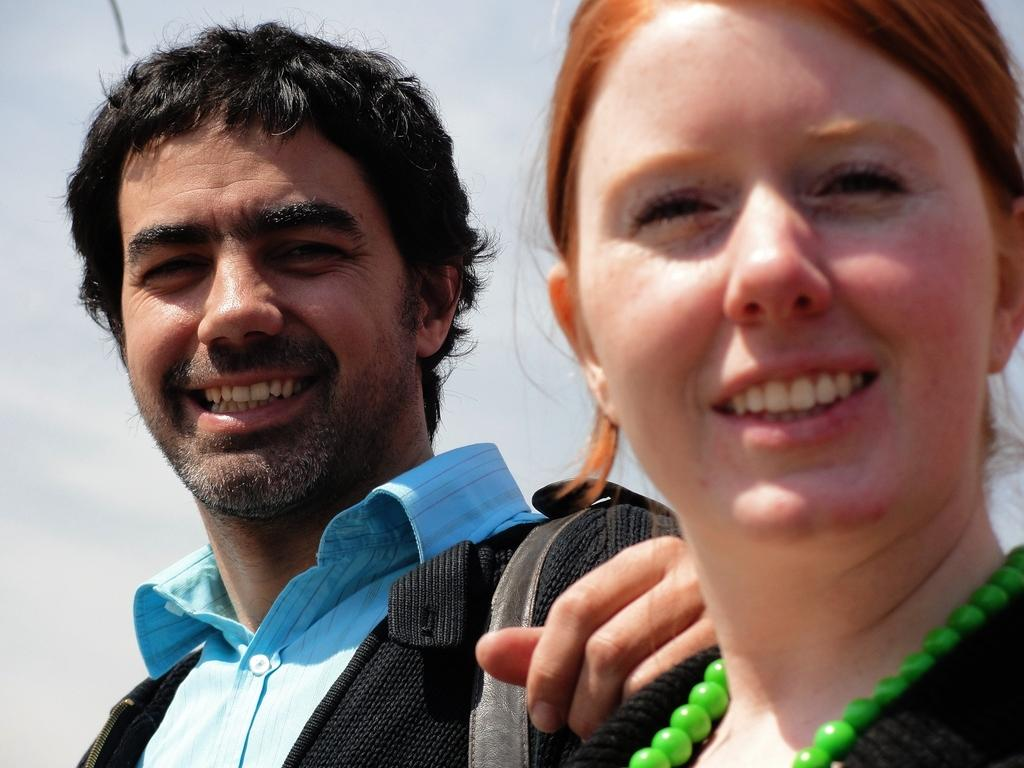Who are the people in the foreground of the image? There is a man and a woman in the foreground of the image. What expressions do the man and woman have in the image? Both the man and woman are smiling in the image. What can be seen in the background of the image? The sky is visible in the background of the image. What type of wine is being served in the image? There is no wine present in the image; it features a man and a woman smiling in the foreground. Can you see any quartz in the image? There is no quartz present in the image. 